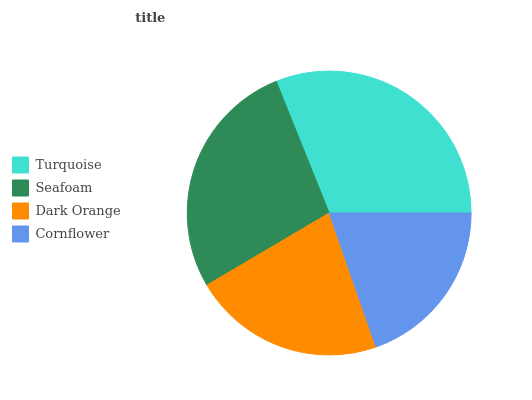Is Cornflower the minimum?
Answer yes or no. Yes. Is Turquoise the maximum?
Answer yes or no. Yes. Is Seafoam the minimum?
Answer yes or no. No. Is Seafoam the maximum?
Answer yes or no. No. Is Turquoise greater than Seafoam?
Answer yes or no. Yes. Is Seafoam less than Turquoise?
Answer yes or no. Yes. Is Seafoam greater than Turquoise?
Answer yes or no. No. Is Turquoise less than Seafoam?
Answer yes or no. No. Is Seafoam the high median?
Answer yes or no. Yes. Is Dark Orange the low median?
Answer yes or no. Yes. Is Turquoise the high median?
Answer yes or no. No. Is Cornflower the low median?
Answer yes or no. No. 